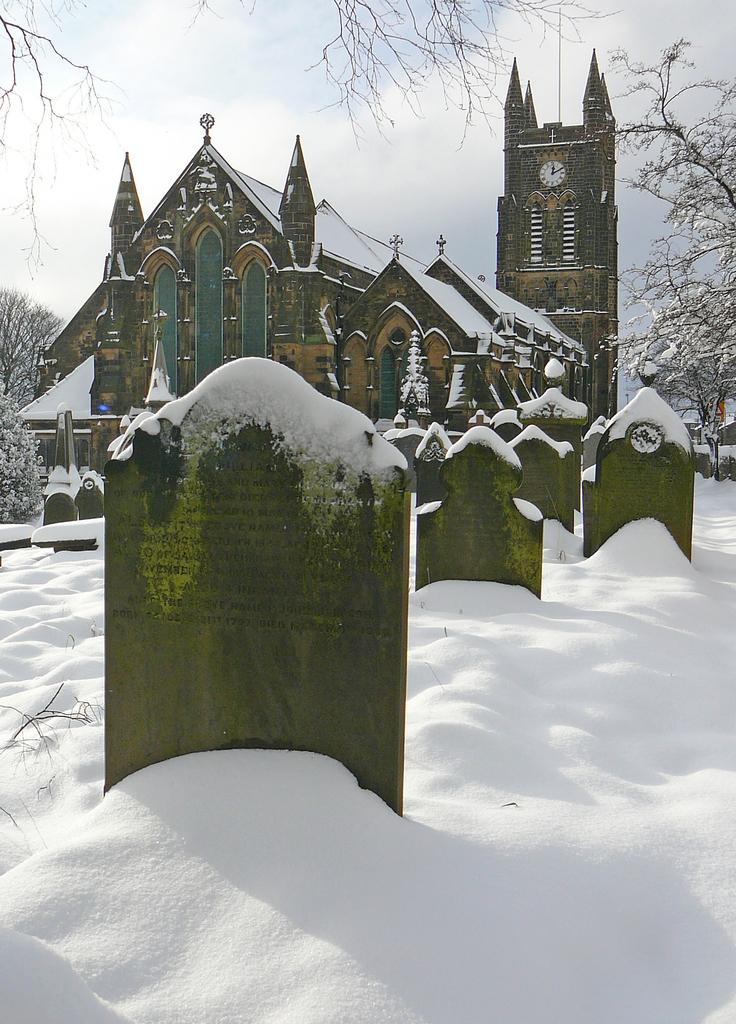How would you summarize this image in a sentence or two? In the picture we can see a church building with a cross symbol on the top of it and behind it, we can see some part of the church building with a clock to it and near the church we can see some grave stones on the snow surface and some snow on it and around the church we can see some trees and in the background we can see a sky. 